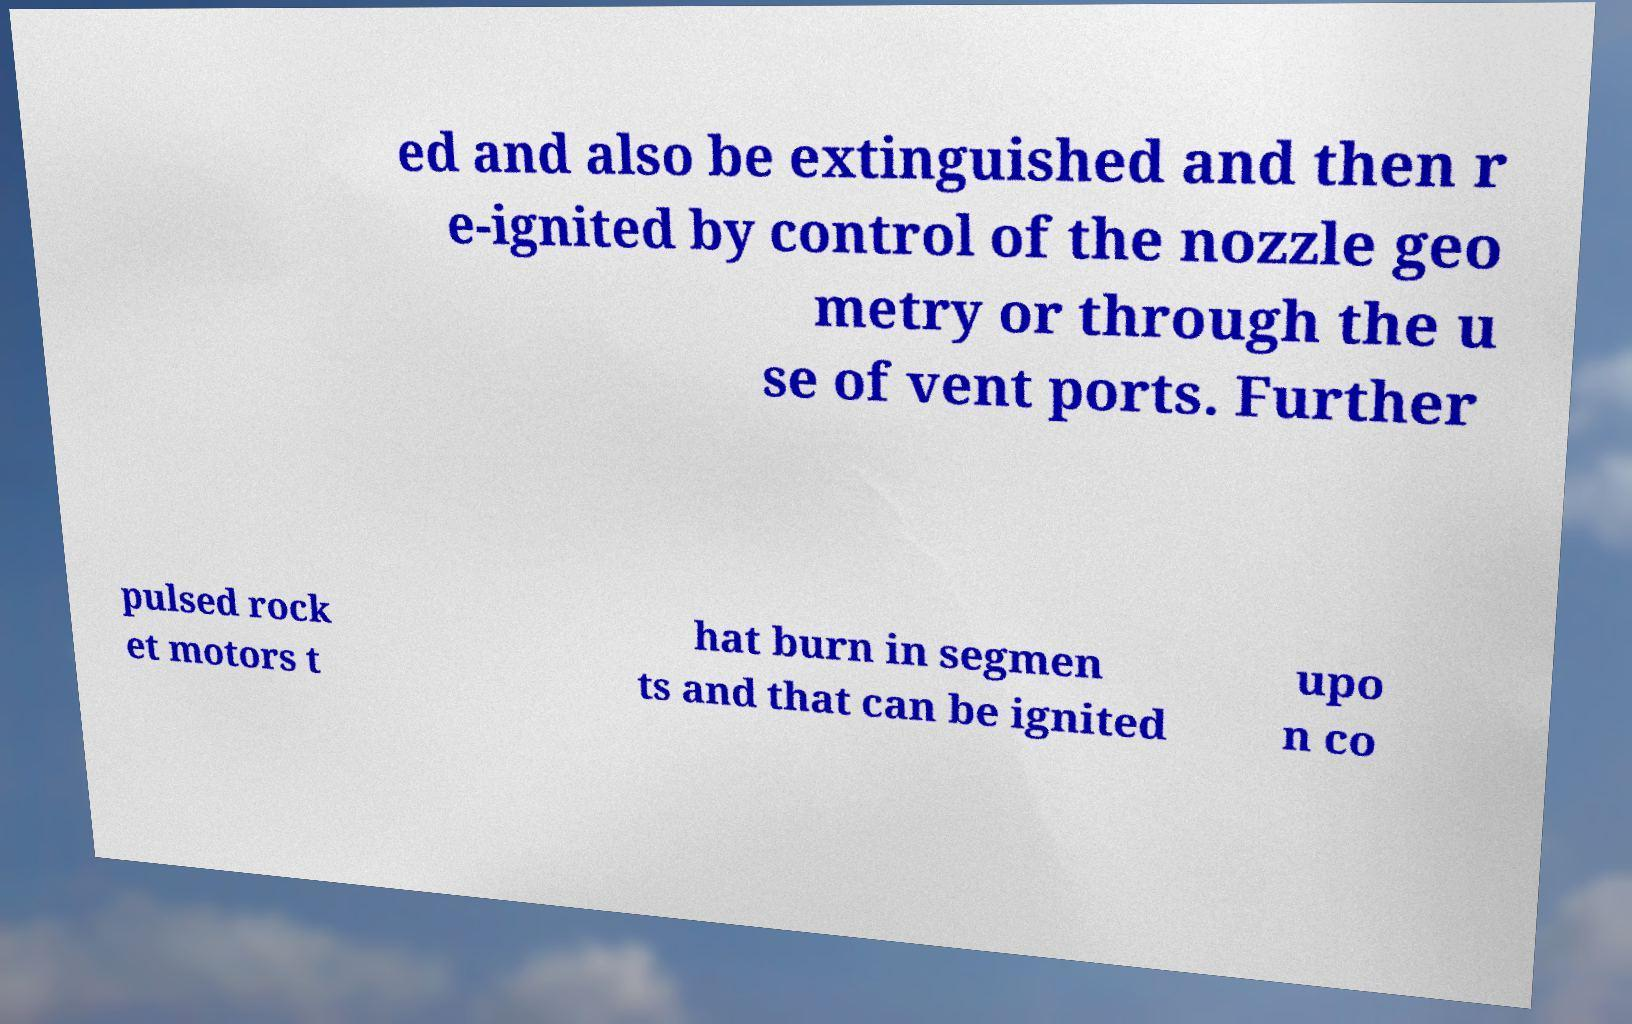Can you accurately transcribe the text from the provided image for me? ed and also be extinguished and then r e-ignited by control of the nozzle geo metry or through the u se of vent ports. Further pulsed rock et motors t hat burn in segmen ts and that can be ignited upo n co 